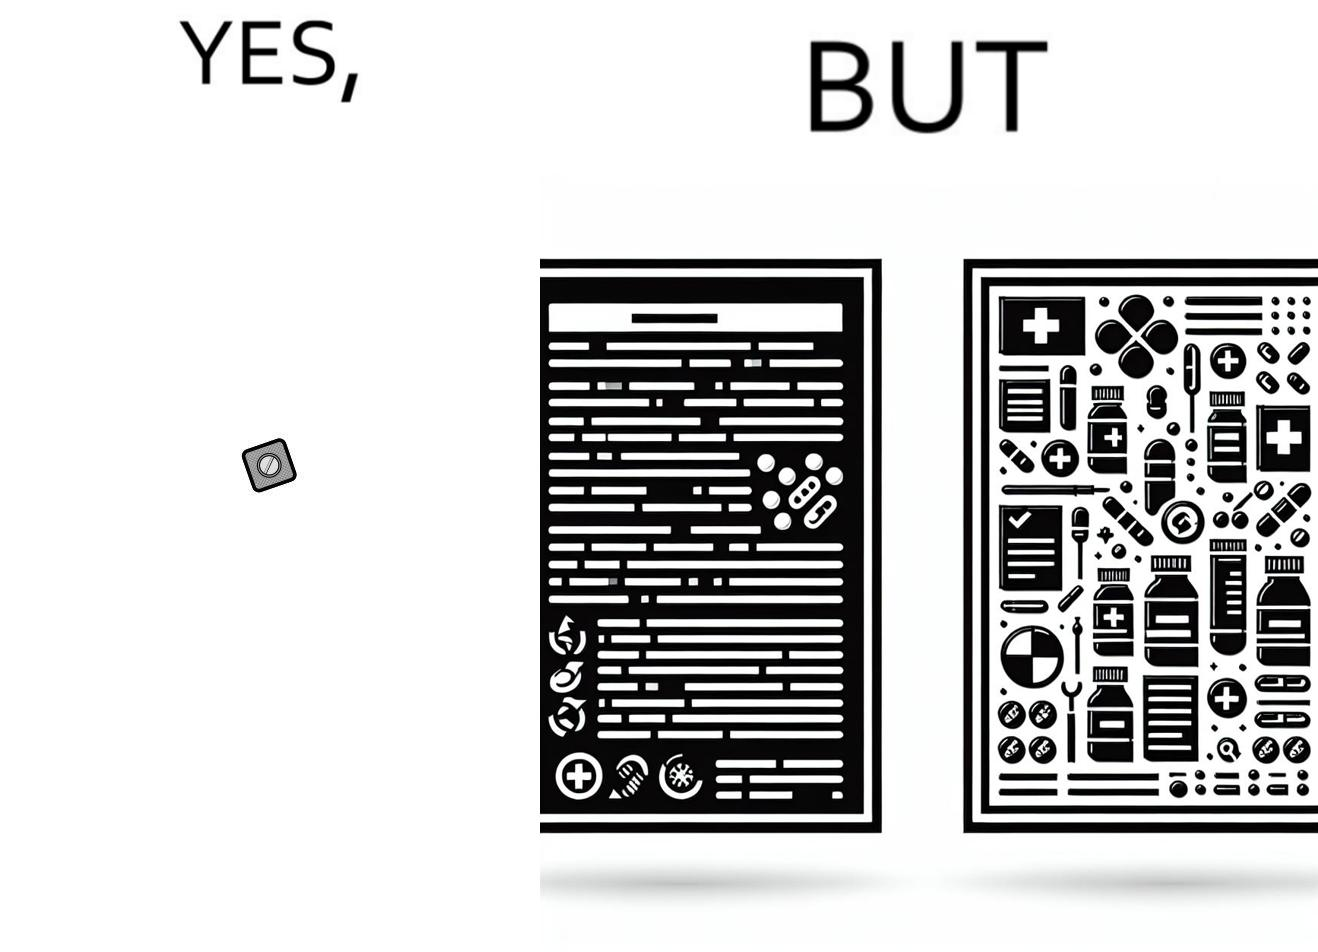Why is this image considered satirical? the irony in this image is a small thing like a medicine very often has instructions and a manual that is extremely long 